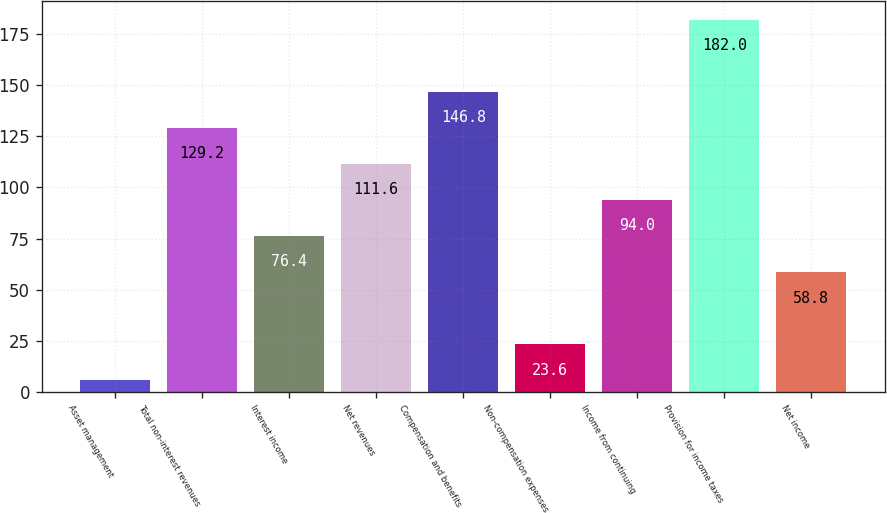Convert chart. <chart><loc_0><loc_0><loc_500><loc_500><bar_chart><fcel>Asset management<fcel>Total non-interest revenues<fcel>Interest income<fcel>Net revenues<fcel>Compensation and benefits<fcel>Non-compensation expenses<fcel>Income from continuing<fcel>Provision for income taxes<fcel>Net income<nl><fcel>6<fcel>129.2<fcel>76.4<fcel>111.6<fcel>146.8<fcel>23.6<fcel>94<fcel>182<fcel>58.8<nl></chart> 